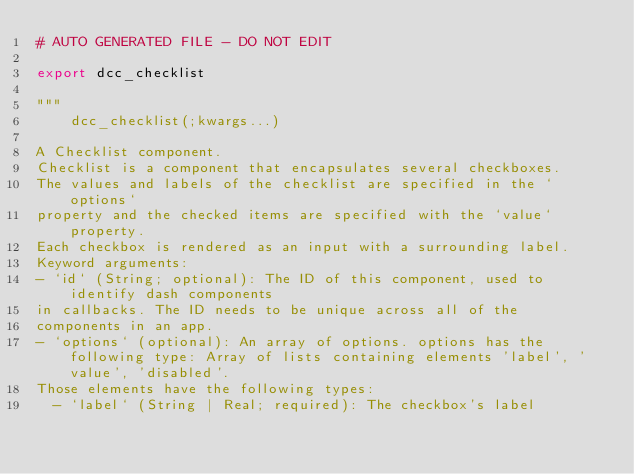<code> <loc_0><loc_0><loc_500><loc_500><_Julia_># AUTO GENERATED FILE - DO NOT EDIT

export dcc_checklist

"""
    dcc_checklist(;kwargs...)

A Checklist component.
Checklist is a component that encapsulates several checkboxes.
The values and labels of the checklist are specified in the `options`
property and the checked items are specified with the `value` property.
Each checkbox is rendered as an input with a surrounding label.
Keyword arguments:
- `id` (String; optional): The ID of this component, used to identify dash components
in callbacks. The ID needs to be unique across all of the
components in an app.
- `options` (optional): An array of options. options has the following type: Array of lists containing elements 'label', 'value', 'disabled'.
Those elements have the following types:
  - `label` (String | Real; required): The checkbox's label</code> 